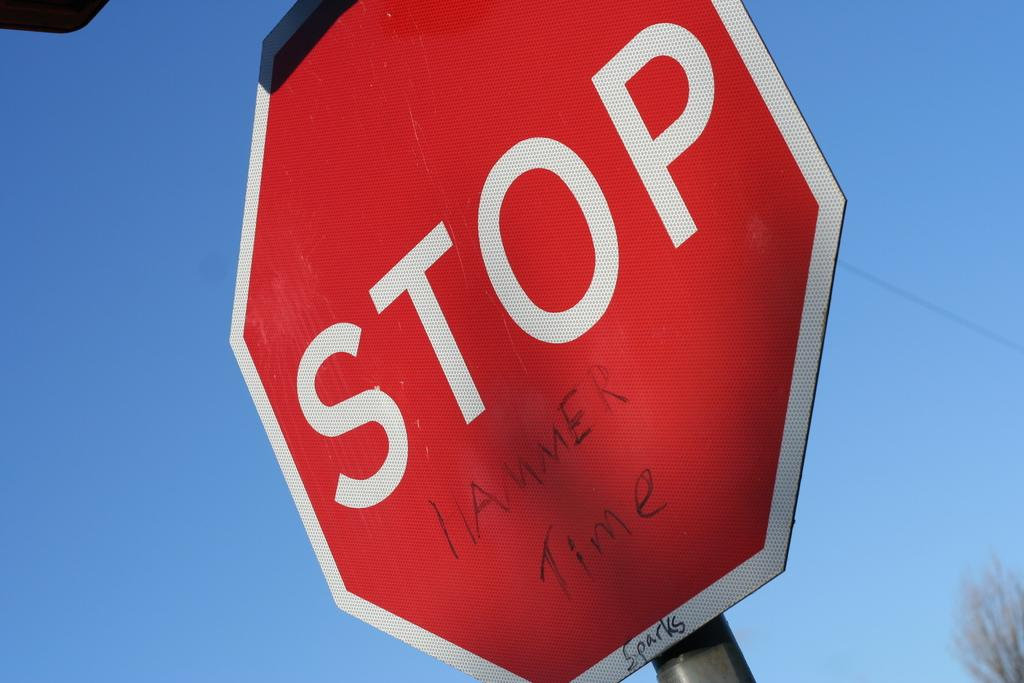<image>
Share a concise interpretation of the image provided. A Stop sign that has been vandalized to read : "Stop Hammer Time". 